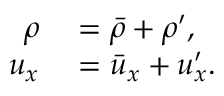Convert formula to latex. <formula><loc_0><loc_0><loc_500><loc_500>\begin{array} { r l } { \rho } & = \bar { \rho } + \rho ^ { \prime } , } \\ { u _ { x } } & = \bar { u } _ { x } + u _ { x } ^ { \prime } . } \end{array}</formula> 